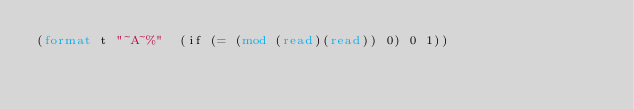Convert code to text. <code><loc_0><loc_0><loc_500><loc_500><_Lisp_>(format t "~A~%"  (if (= (mod (read)(read)) 0) 0 1))</code> 